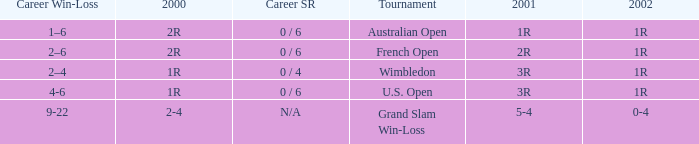Which career win-loss record has a 1r in 2002, a 2r in 2000 and a 2r in 2001? 2–6. 